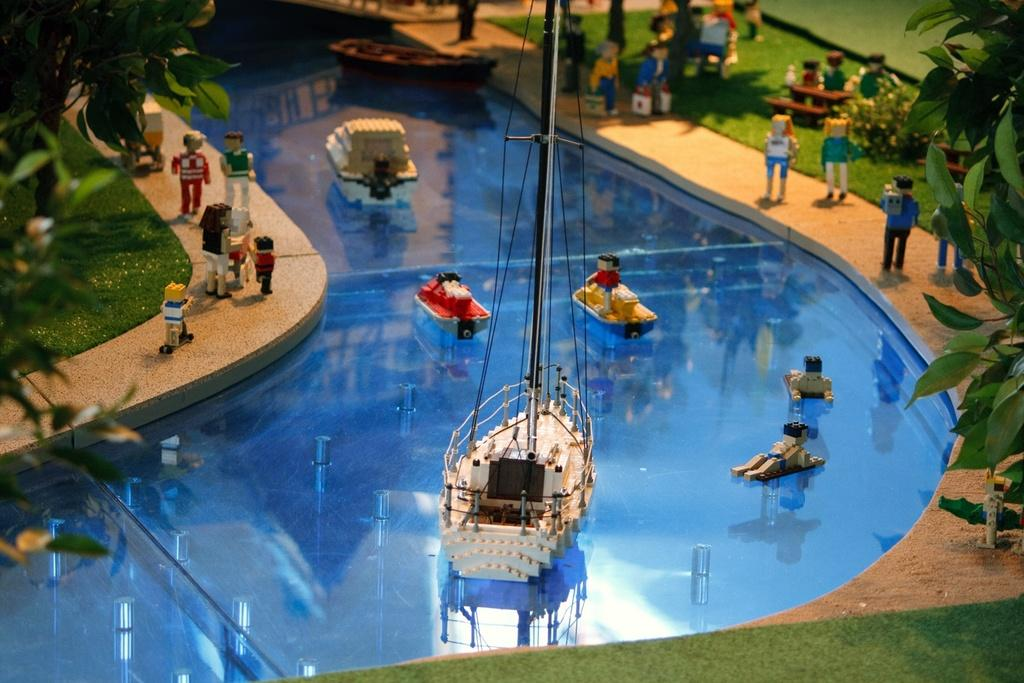What is the main subject of the image? The main subject of the image is a miniature. What type of pencil can be seen being used to draw the miniature in the image? There is no pencil visible in the image, and therefore no such activity can be observed. 